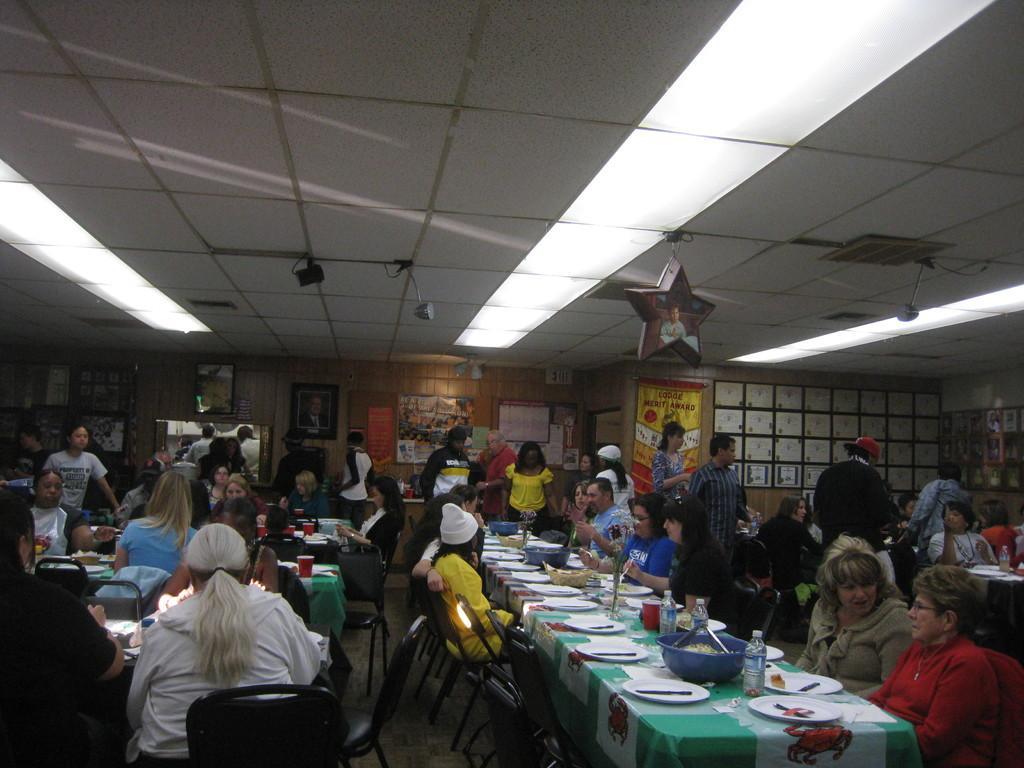How would you summarize this image in a sentence or two? In this image there are group of people,few people are sitting on the chair. On the table there is a plate,knife,bowl,water bottle and a food. Table is covered with a cloth. At the background there are frames on the wall and the banner hanging to the wall. 